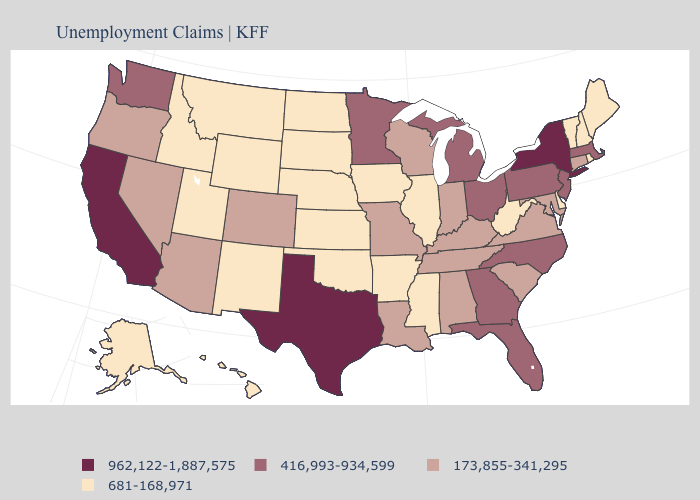Does the first symbol in the legend represent the smallest category?
Short answer required. No. Does the first symbol in the legend represent the smallest category?
Write a very short answer. No. What is the value of New Mexico?
Short answer required. 681-168,971. Does Minnesota have a lower value than New York?
Short answer required. Yes. What is the value of Connecticut?
Be succinct. 173,855-341,295. What is the value of Virginia?
Keep it brief. 173,855-341,295. Name the states that have a value in the range 681-168,971?
Short answer required. Alaska, Arkansas, Delaware, Hawaii, Idaho, Illinois, Iowa, Kansas, Maine, Mississippi, Montana, Nebraska, New Hampshire, New Mexico, North Dakota, Oklahoma, Rhode Island, South Dakota, Utah, Vermont, West Virginia, Wyoming. Which states have the lowest value in the USA?
Quick response, please. Alaska, Arkansas, Delaware, Hawaii, Idaho, Illinois, Iowa, Kansas, Maine, Mississippi, Montana, Nebraska, New Hampshire, New Mexico, North Dakota, Oklahoma, Rhode Island, South Dakota, Utah, Vermont, West Virginia, Wyoming. What is the value of Rhode Island?
Keep it brief. 681-168,971. What is the value of New York?
Answer briefly. 962,122-1,887,575. What is the highest value in states that border Kentucky?
Short answer required. 416,993-934,599. Name the states that have a value in the range 962,122-1,887,575?
Be succinct. California, New York, Texas. Which states have the lowest value in the South?
Concise answer only. Arkansas, Delaware, Mississippi, Oklahoma, West Virginia. What is the lowest value in the West?
Write a very short answer. 681-168,971. Does Arkansas have the same value as Pennsylvania?
Write a very short answer. No. 